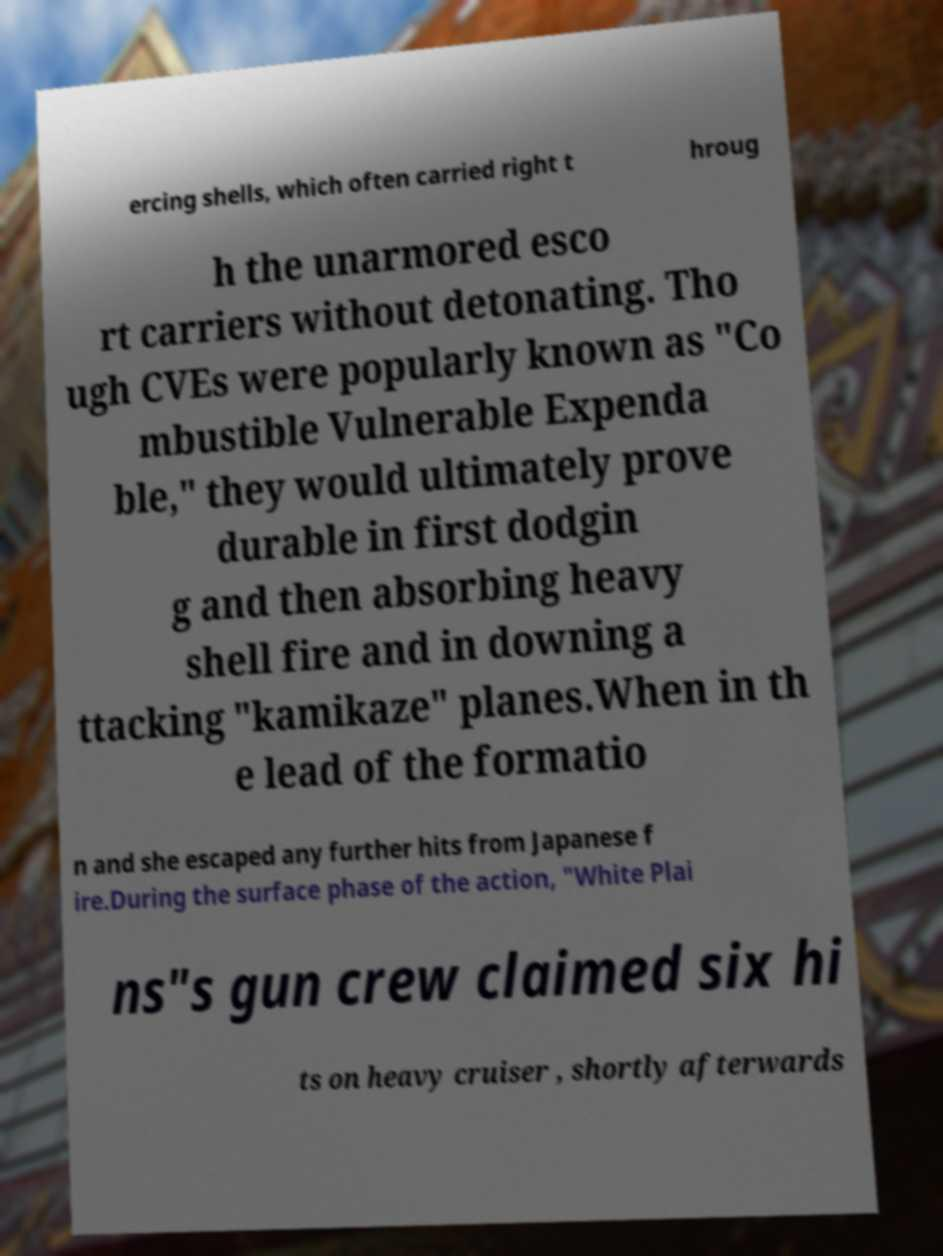There's text embedded in this image that I need extracted. Can you transcribe it verbatim? ercing shells, which often carried right t hroug h the unarmored esco rt carriers without detonating. Tho ugh CVEs were popularly known as "Co mbustible Vulnerable Expenda ble," they would ultimately prove durable in first dodgin g and then absorbing heavy shell fire and in downing a ttacking "kamikaze" planes.When in th e lead of the formatio n and she escaped any further hits from Japanese f ire.During the surface phase of the action, "White Plai ns"s gun crew claimed six hi ts on heavy cruiser , shortly afterwards 